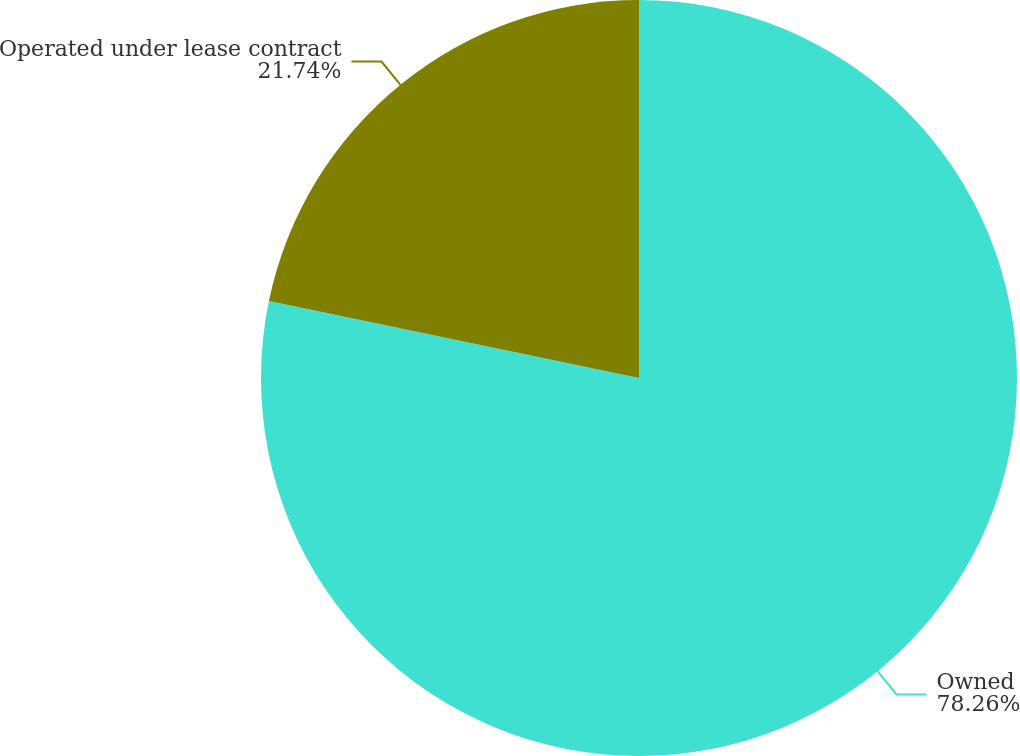Convert chart. <chart><loc_0><loc_0><loc_500><loc_500><pie_chart><fcel>Owned<fcel>Operated under lease contract<nl><fcel>78.26%<fcel>21.74%<nl></chart> 